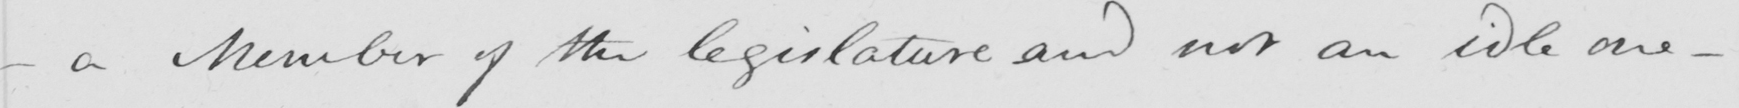Please provide the text content of this handwritten line. _  a Member of the legislature and not an idle one  _ 